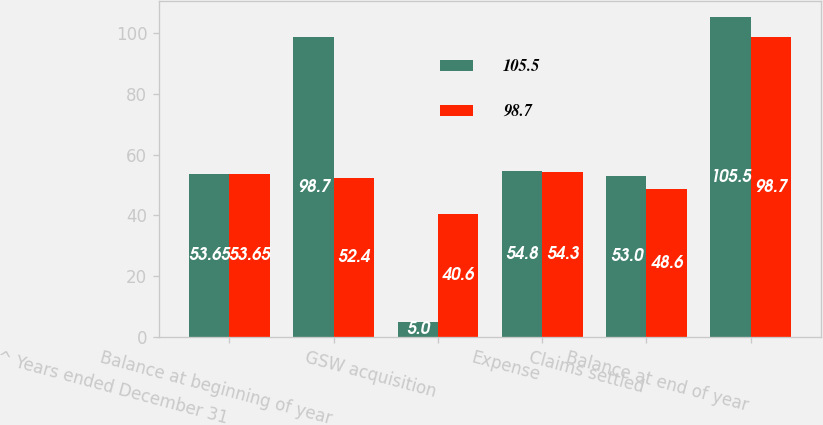<chart> <loc_0><loc_0><loc_500><loc_500><stacked_bar_chart><ecel><fcel>^ Years ended December 31<fcel>Balance at beginning of year<fcel>GSW acquisition<fcel>Expense<fcel>Claims settled<fcel>Balance at end of year<nl><fcel>105.5<fcel>53.65<fcel>98.7<fcel>5<fcel>54.8<fcel>53<fcel>105.5<nl><fcel>98.7<fcel>53.65<fcel>52.4<fcel>40.6<fcel>54.3<fcel>48.6<fcel>98.7<nl></chart> 